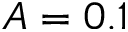Convert formula to latex. <formula><loc_0><loc_0><loc_500><loc_500>A = 0 . 1</formula> 